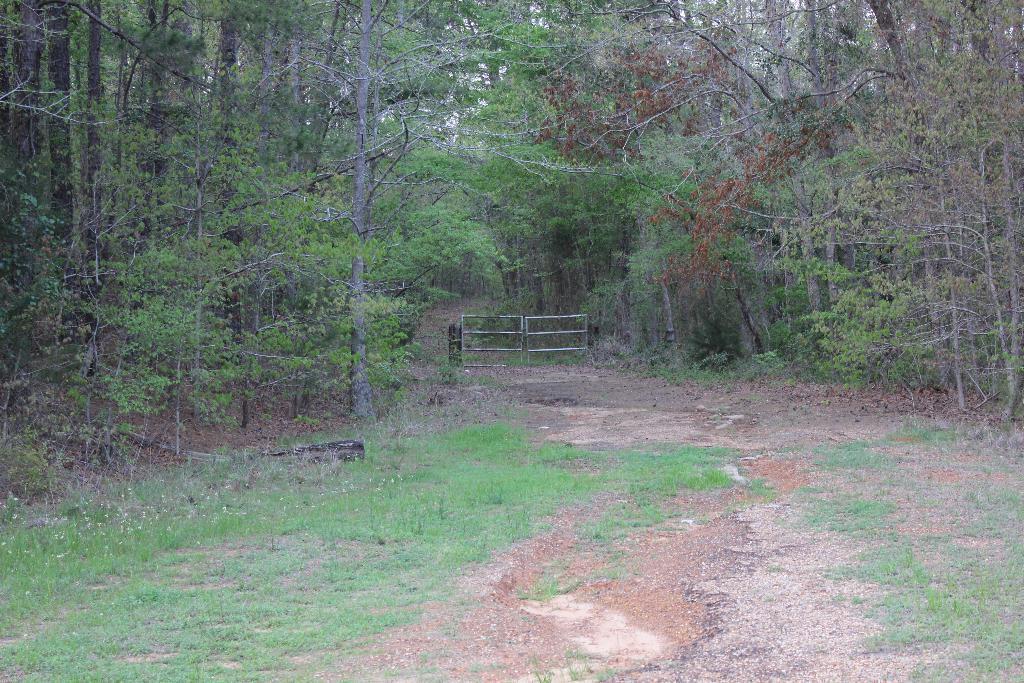How would you summarize this image in a sentence or two? In this picture there are trees. At the back there is a gate. At the top it looks like sky. At the bottom there is grass and there is ground. 